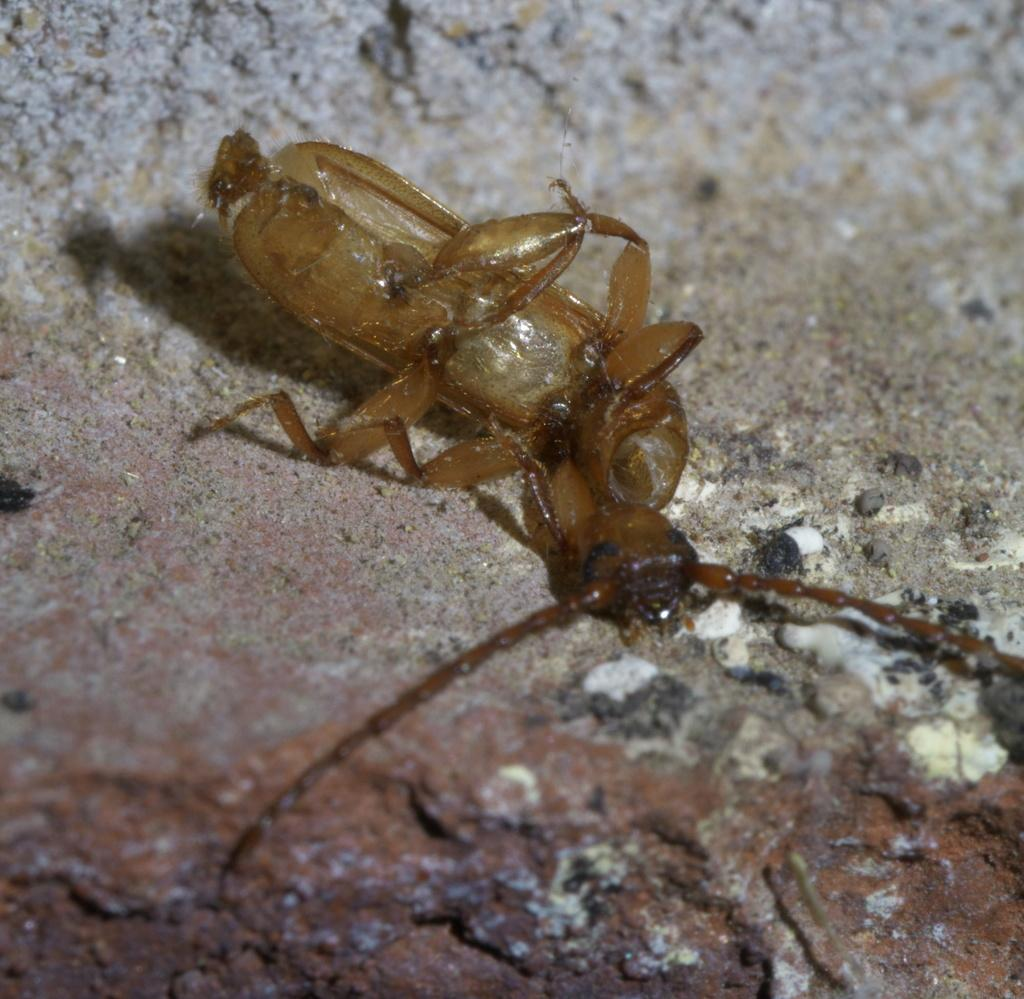What type of creature is in the image? There is an insect in the image. Where is the insect located? The insect is on a rock. What type of fruit is the insect holding in the image? There is no fruit present in the image, and the insect is not holding anything. 